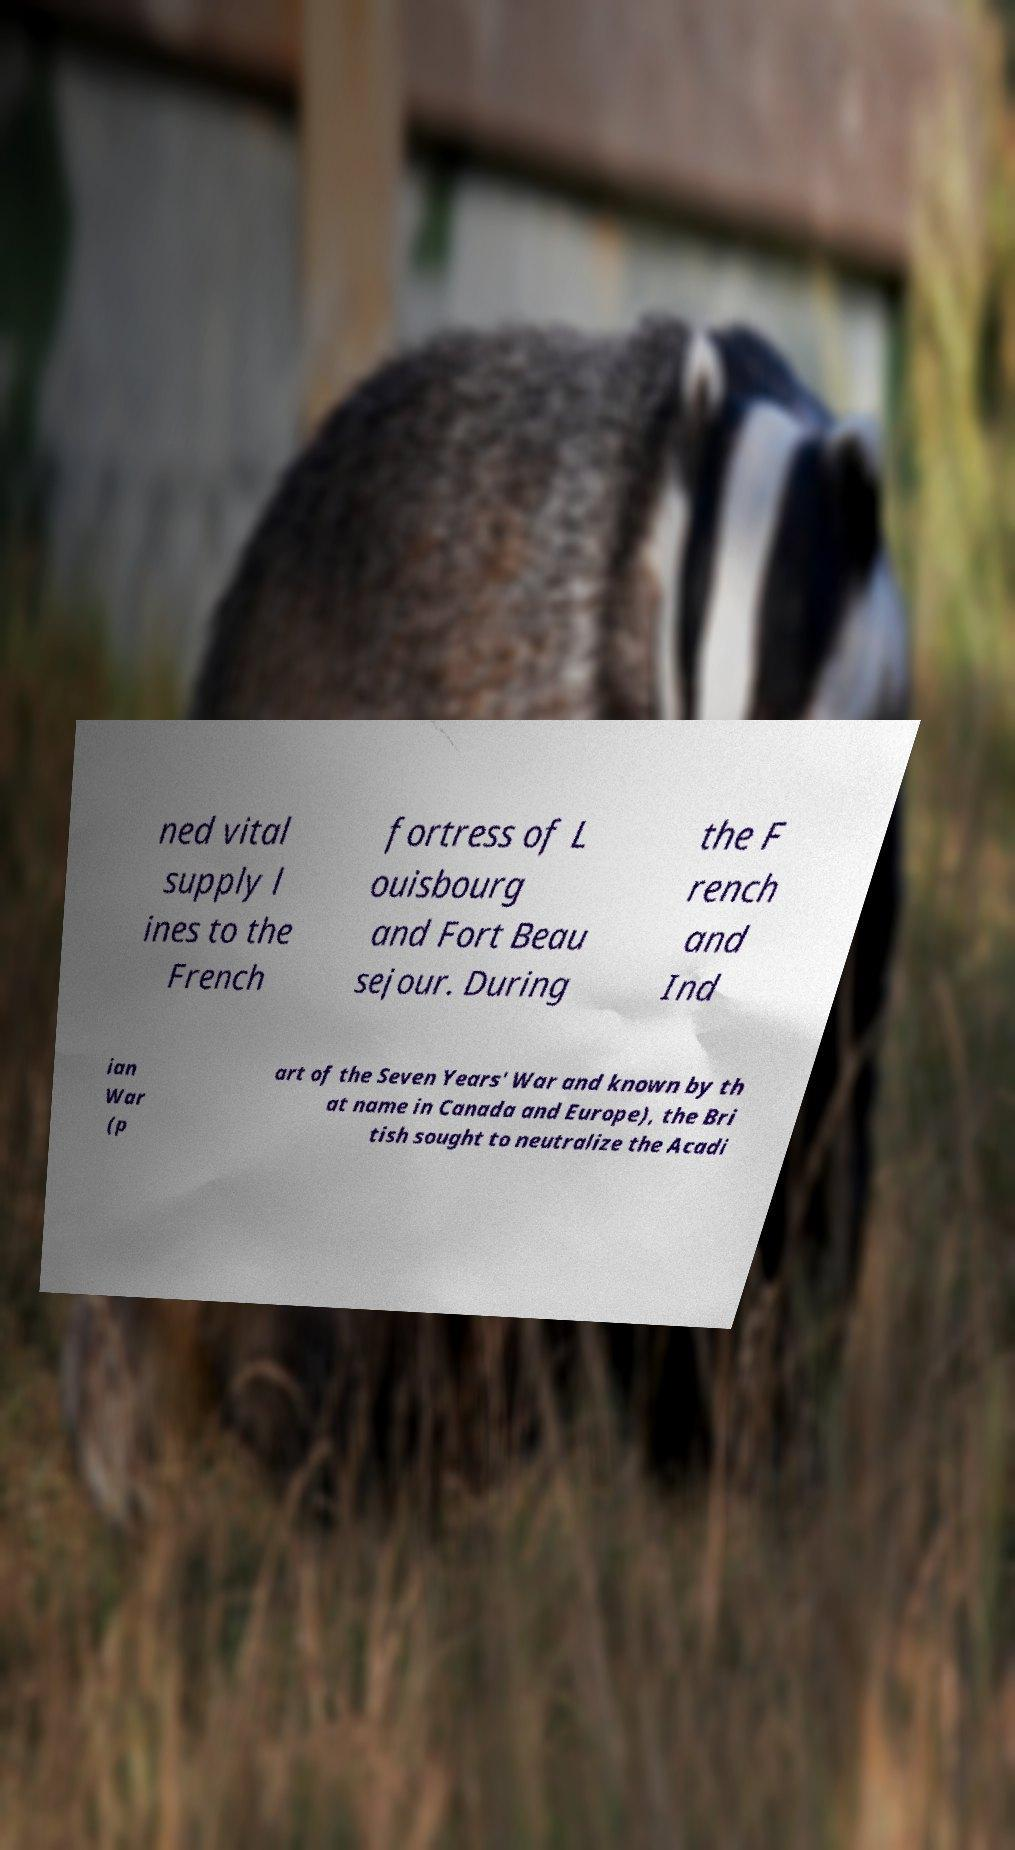I need the written content from this picture converted into text. Can you do that? ned vital supply l ines to the French fortress of L ouisbourg and Fort Beau sejour. During the F rench and Ind ian War (p art of the Seven Years' War and known by th at name in Canada and Europe), the Bri tish sought to neutralize the Acadi 